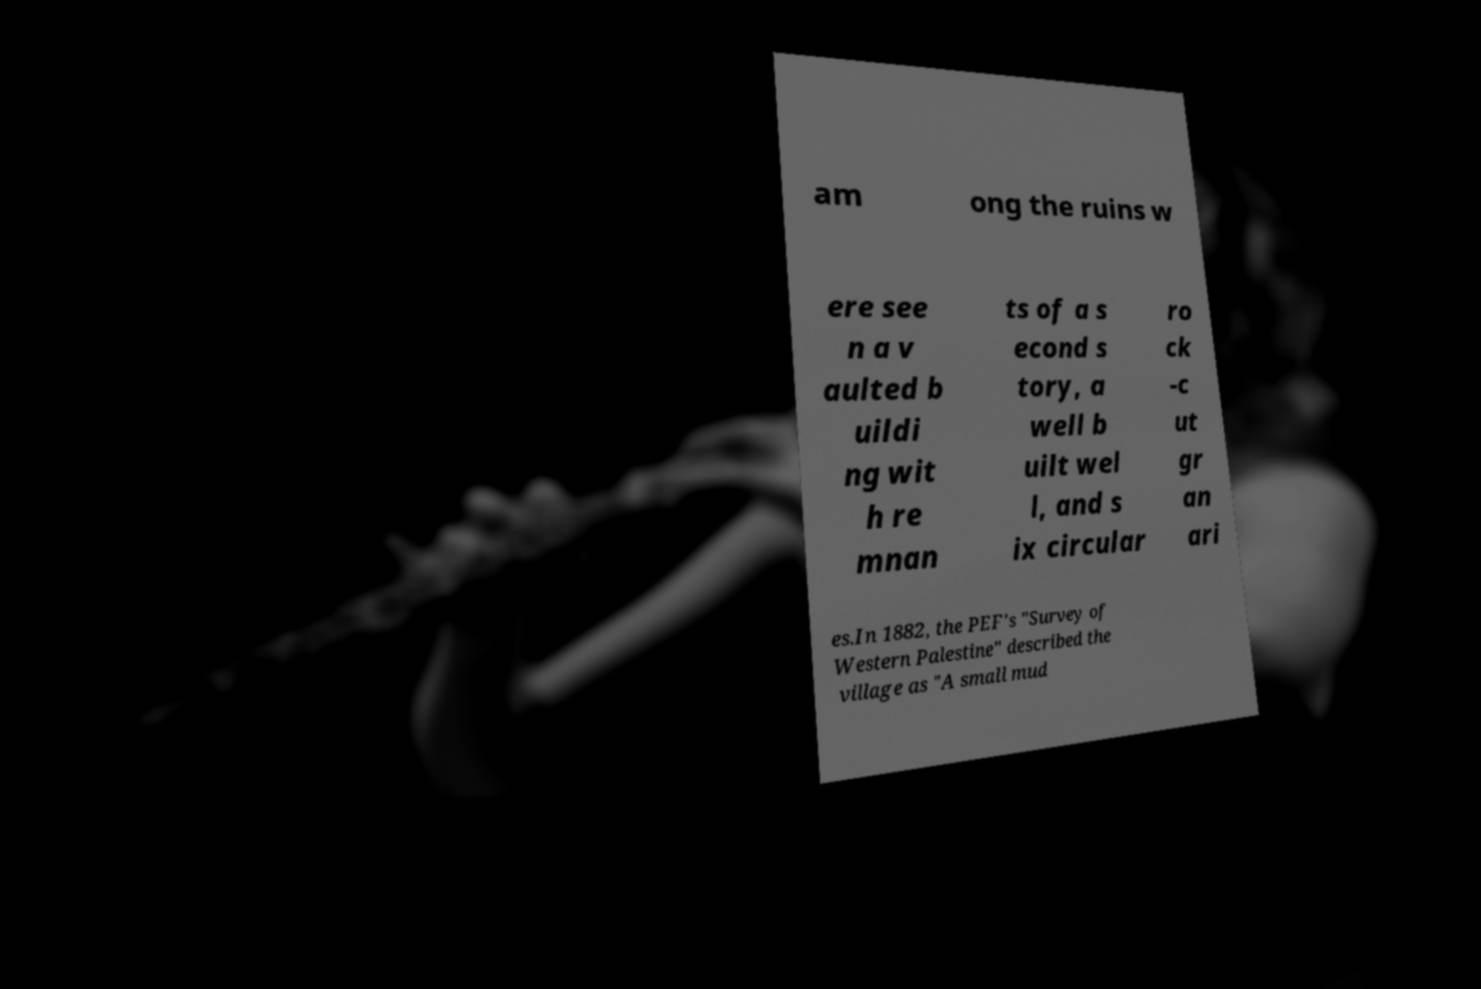I need the written content from this picture converted into text. Can you do that? am ong the ruins w ere see n a v aulted b uildi ng wit h re mnan ts of a s econd s tory, a well b uilt wel l, and s ix circular ro ck -c ut gr an ari es.In 1882, the PEF's "Survey of Western Palestine" described the village as "A small mud 